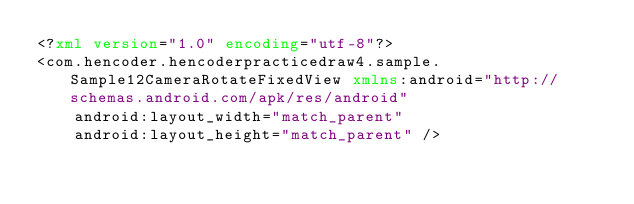<code> <loc_0><loc_0><loc_500><loc_500><_XML_><?xml version="1.0" encoding="utf-8"?>
<com.hencoder.hencoderpracticedraw4.sample.Sample12CameraRotateFixedView xmlns:android="http://schemas.android.com/apk/res/android"
    android:layout_width="match_parent"
    android:layout_height="match_parent" /></code> 